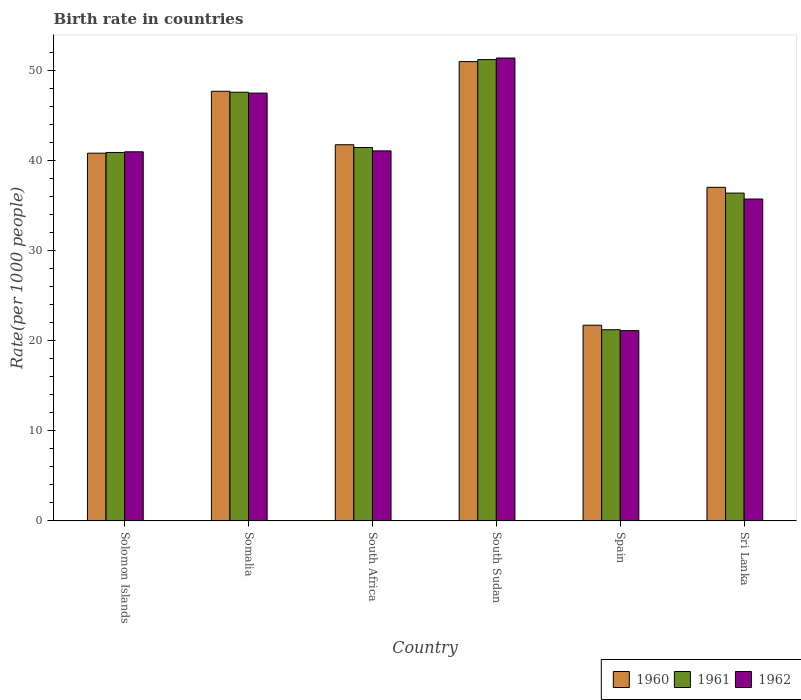Are the number of bars on each tick of the X-axis equal?
Keep it short and to the point. Yes. How many bars are there on the 5th tick from the left?
Your response must be concise. 3. What is the label of the 6th group of bars from the left?
Provide a short and direct response. Sri Lanka. In how many cases, is the number of bars for a given country not equal to the number of legend labels?
Your response must be concise. 0. What is the birth rate in 1961 in South Sudan?
Your answer should be very brief. 51.16. Across all countries, what is the maximum birth rate in 1960?
Provide a short and direct response. 50.95. Across all countries, what is the minimum birth rate in 1961?
Offer a terse response. 21.2. In which country was the birth rate in 1960 maximum?
Offer a very short reply. South Sudan. In which country was the birth rate in 1962 minimum?
Offer a very short reply. Spain. What is the total birth rate in 1961 in the graph?
Your answer should be compact. 238.54. What is the difference between the birth rate in 1962 in Solomon Islands and that in Spain?
Provide a short and direct response. 19.84. What is the difference between the birth rate in 1962 in Sri Lanka and the birth rate in 1961 in Spain?
Keep it short and to the point. 14.5. What is the average birth rate in 1960 per country?
Provide a short and direct response. 39.97. What is the difference between the birth rate of/in 1960 and birth rate of/in 1961 in South Sudan?
Make the answer very short. -0.22. What is the ratio of the birth rate in 1961 in South Africa to that in Spain?
Your answer should be very brief. 1.95. Is the birth rate in 1960 in Solomon Islands less than that in Somalia?
Provide a short and direct response. Yes. Is the difference between the birth rate in 1960 in South Sudan and Sri Lanka greater than the difference between the birth rate in 1961 in South Sudan and Sri Lanka?
Make the answer very short. No. What is the difference between the highest and the second highest birth rate in 1962?
Give a very brief answer. -10.3. What is the difference between the highest and the lowest birth rate in 1961?
Provide a succinct answer. 29.96. What does the 3rd bar from the left in Somalia represents?
Offer a very short reply. 1962. What does the 3rd bar from the right in South Sudan represents?
Your answer should be very brief. 1960. How many bars are there?
Provide a succinct answer. 18. Are all the bars in the graph horizontal?
Provide a succinct answer. No. What is the difference between two consecutive major ticks on the Y-axis?
Keep it short and to the point. 10. Are the values on the major ticks of Y-axis written in scientific E-notation?
Provide a short and direct response. No. Does the graph contain any zero values?
Make the answer very short. No. What is the title of the graph?
Provide a succinct answer. Birth rate in countries. What is the label or title of the X-axis?
Keep it short and to the point. Country. What is the label or title of the Y-axis?
Your answer should be compact. Rate(per 1000 people). What is the Rate(per 1000 people) of 1960 in Solomon Islands?
Offer a very short reply. 40.78. What is the Rate(per 1000 people) in 1961 in Solomon Islands?
Offer a very short reply. 40.86. What is the Rate(per 1000 people) in 1962 in Solomon Islands?
Provide a succinct answer. 40.94. What is the Rate(per 1000 people) of 1960 in Somalia?
Provide a short and direct response. 47.65. What is the Rate(per 1000 people) in 1961 in Somalia?
Your answer should be very brief. 47.54. What is the Rate(per 1000 people) in 1962 in Somalia?
Offer a very short reply. 47.45. What is the Rate(per 1000 people) in 1960 in South Africa?
Make the answer very short. 41.72. What is the Rate(per 1000 people) in 1961 in South Africa?
Offer a very short reply. 41.41. What is the Rate(per 1000 people) of 1962 in South Africa?
Your answer should be compact. 41.04. What is the Rate(per 1000 people) in 1960 in South Sudan?
Your response must be concise. 50.95. What is the Rate(per 1000 people) of 1961 in South Sudan?
Make the answer very short. 51.16. What is the Rate(per 1000 people) of 1962 in South Sudan?
Provide a short and direct response. 51.34. What is the Rate(per 1000 people) in 1960 in Spain?
Give a very brief answer. 21.7. What is the Rate(per 1000 people) in 1961 in Spain?
Keep it short and to the point. 21.2. What is the Rate(per 1000 people) of 1962 in Spain?
Your response must be concise. 21.1. What is the Rate(per 1000 people) of 1960 in Sri Lanka?
Offer a very short reply. 37. What is the Rate(per 1000 people) of 1961 in Sri Lanka?
Give a very brief answer. 36.36. What is the Rate(per 1000 people) in 1962 in Sri Lanka?
Your response must be concise. 35.7. Across all countries, what is the maximum Rate(per 1000 people) in 1960?
Your response must be concise. 50.95. Across all countries, what is the maximum Rate(per 1000 people) of 1961?
Offer a very short reply. 51.16. Across all countries, what is the maximum Rate(per 1000 people) in 1962?
Your answer should be compact. 51.34. Across all countries, what is the minimum Rate(per 1000 people) of 1960?
Ensure brevity in your answer.  21.7. Across all countries, what is the minimum Rate(per 1000 people) in 1961?
Your answer should be compact. 21.2. Across all countries, what is the minimum Rate(per 1000 people) of 1962?
Provide a succinct answer. 21.1. What is the total Rate(per 1000 people) of 1960 in the graph?
Give a very brief answer. 239.79. What is the total Rate(per 1000 people) of 1961 in the graph?
Ensure brevity in your answer.  238.54. What is the total Rate(per 1000 people) in 1962 in the graph?
Your response must be concise. 237.56. What is the difference between the Rate(per 1000 people) of 1960 in Solomon Islands and that in Somalia?
Offer a very short reply. -6.87. What is the difference between the Rate(per 1000 people) of 1961 in Solomon Islands and that in Somalia?
Provide a succinct answer. -6.68. What is the difference between the Rate(per 1000 people) of 1962 in Solomon Islands and that in Somalia?
Ensure brevity in your answer.  -6.51. What is the difference between the Rate(per 1000 people) of 1960 in Solomon Islands and that in South Africa?
Your answer should be compact. -0.94. What is the difference between the Rate(per 1000 people) of 1961 in Solomon Islands and that in South Africa?
Keep it short and to the point. -0.55. What is the difference between the Rate(per 1000 people) of 1962 in Solomon Islands and that in South Africa?
Your answer should be very brief. -0.1. What is the difference between the Rate(per 1000 people) of 1960 in Solomon Islands and that in South Sudan?
Provide a succinct answer. -10.16. What is the difference between the Rate(per 1000 people) in 1961 in Solomon Islands and that in South Sudan?
Your answer should be very brief. -10.3. What is the difference between the Rate(per 1000 people) of 1962 in Solomon Islands and that in South Sudan?
Keep it short and to the point. -10.4. What is the difference between the Rate(per 1000 people) of 1960 in Solomon Islands and that in Spain?
Ensure brevity in your answer.  19.08. What is the difference between the Rate(per 1000 people) of 1961 in Solomon Islands and that in Spain?
Make the answer very short. 19.66. What is the difference between the Rate(per 1000 people) in 1962 in Solomon Islands and that in Spain?
Your answer should be compact. 19.84. What is the difference between the Rate(per 1000 people) in 1960 in Solomon Islands and that in Sri Lanka?
Your answer should be compact. 3.79. What is the difference between the Rate(per 1000 people) of 1961 in Solomon Islands and that in Sri Lanka?
Ensure brevity in your answer.  4.51. What is the difference between the Rate(per 1000 people) in 1962 in Solomon Islands and that in Sri Lanka?
Give a very brief answer. 5.24. What is the difference between the Rate(per 1000 people) of 1960 in Somalia and that in South Africa?
Your answer should be compact. 5.93. What is the difference between the Rate(per 1000 people) in 1961 in Somalia and that in South Africa?
Keep it short and to the point. 6.13. What is the difference between the Rate(per 1000 people) in 1962 in Somalia and that in South Africa?
Ensure brevity in your answer.  6.41. What is the difference between the Rate(per 1000 people) of 1960 in Somalia and that in South Sudan?
Offer a very short reply. -3.29. What is the difference between the Rate(per 1000 people) of 1961 in Somalia and that in South Sudan?
Offer a very short reply. -3.62. What is the difference between the Rate(per 1000 people) of 1962 in Somalia and that in South Sudan?
Offer a very short reply. -3.89. What is the difference between the Rate(per 1000 people) of 1960 in Somalia and that in Spain?
Offer a very short reply. 25.95. What is the difference between the Rate(per 1000 people) of 1961 in Somalia and that in Spain?
Keep it short and to the point. 26.34. What is the difference between the Rate(per 1000 people) of 1962 in Somalia and that in Spain?
Give a very brief answer. 26.35. What is the difference between the Rate(per 1000 people) of 1960 in Somalia and that in Sri Lanka?
Your response must be concise. 10.65. What is the difference between the Rate(per 1000 people) of 1961 in Somalia and that in Sri Lanka?
Your answer should be compact. 11.19. What is the difference between the Rate(per 1000 people) of 1962 in Somalia and that in Sri Lanka?
Provide a succinct answer. 11.75. What is the difference between the Rate(per 1000 people) in 1960 in South Africa and that in South Sudan?
Offer a very short reply. -9.23. What is the difference between the Rate(per 1000 people) of 1961 in South Africa and that in South Sudan?
Offer a very short reply. -9.75. What is the difference between the Rate(per 1000 people) of 1962 in South Africa and that in South Sudan?
Your response must be concise. -10.3. What is the difference between the Rate(per 1000 people) in 1960 in South Africa and that in Spain?
Keep it short and to the point. 20.02. What is the difference between the Rate(per 1000 people) of 1961 in South Africa and that in Spain?
Give a very brief answer. 20.21. What is the difference between the Rate(per 1000 people) of 1962 in South Africa and that in Spain?
Offer a terse response. 19.94. What is the difference between the Rate(per 1000 people) in 1960 in South Africa and that in Sri Lanka?
Your answer should be compact. 4.72. What is the difference between the Rate(per 1000 people) of 1961 in South Africa and that in Sri Lanka?
Your answer should be compact. 5.06. What is the difference between the Rate(per 1000 people) in 1962 in South Africa and that in Sri Lanka?
Your answer should be compact. 5.34. What is the difference between the Rate(per 1000 people) of 1960 in South Sudan and that in Spain?
Offer a terse response. 29.25. What is the difference between the Rate(per 1000 people) in 1961 in South Sudan and that in Spain?
Your answer should be compact. 29.96. What is the difference between the Rate(per 1000 people) in 1962 in South Sudan and that in Spain?
Your answer should be compact. 30.24. What is the difference between the Rate(per 1000 people) in 1960 in South Sudan and that in Sri Lanka?
Give a very brief answer. 13.95. What is the difference between the Rate(per 1000 people) of 1961 in South Sudan and that in Sri Lanka?
Offer a terse response. 14.81. What is the difference between the Rate(per 1000 people) in 1962 in South Sudan and that in Sri Lanka?
Make the answer very short. 15.64. What is the difference between the Rate(per 1000 people) in 1960 in Spain and that in Sri Lanka?
Offer a terse response. -15.3. What is the difference between the Rate(per 1000 people) of 1961 in Spain and that in Sri Lanka?
Keep it short and to the point. -15.16. What is the difference between the Rate(per 1000 people) in 1962 in Spain and that in Sri Lanka?
Provide a succinct answer. -14.6. What is the difference between the Rate(per 1000 people) of 1960 in Solomon Islands and the Rate(per 1000 people) of 1961 in Somalia?
Make the answer very short. -6.76. What is the difference between the Rate(per 1000 people) of 1960 in Solomon Islands and the Rate(per 1000 people) of 1962 in Somalia?
Provide a short and direct response. -6.67. What is the difference between the Rate(per 1000 people) in 1961 in Solomon Islands and the Rate(per 1000 people) in 1962 in Somalia?
Give a very brief answer. -6.58. What is the difference between the Rate(per 1000 people) of 1960 in Solomon Islands and the Rate(per 1000 people) of 1961 in South Africa?
Ensure brevity in your answer.  -0.63. What is the difference between the Rate(per 1000 people) in 1960 in Solomon Islands and the Rate(per 1000 people) in 1962 in South Africa?
Give a very brief answer. -0.26. What is the difference between the Rate(per 1000 people) of 1961 in Solomon Islands and the Rate(per 1000 people) of 1962 in South Africa?
Make the answer very short. -0.17. What is the difference between the Rate(per 1000 people) of 1960 in Solomon Islands and the Rate(per 1000 people) of 1961 in South Sudan?
Ensure brevity in your answer.  -10.38. What is the difference between the Rate(per 1000 people) of 1960 in Solomon Islands and the Rate(per 1000 people) of 1962 in South Sudan?
Ensure brevity in your answer.  -10.56. What is the difference between the Rate(per 1000 people) in 1961 in Solomon Islands and the Rate(per 1000 people) in 1962 in South Sudan?
Offer a very short reply. -10.48. What is the difference between the Rate(per 1000 people) in 1960 in Solomon Islands and the Rate(per 1000 people) in 1961 in Spain?
Offer a terse response. 19.58. What is the difference between the Rate(per 1000 people) in 1960 in Solomon Islands and the Rate(per 1000 people) in 1962 in Spain?
Give a very brief answer. 19.68. What is the difference between the Rate(per 1000 people) of 1961 in Solomon Islands and the Rate(per 1000 people) of 1962 in Spain?
Provide a succinct answer. 19.76. What is the difference between the Rate(per 1000 people) of 1960 in Solomon Islands and the Rate(per 1000 people) of 1961 in Sri Lanka?
Offer a very short reply. 4.43. What is the difference between the Rate(per 1000 people) in 1960 in Solomon Islands and the Rate(per 1000 people) in 1962 in Sri Lanka?
Your response must be concise. 5.08. What is the difference between the Rate(per 1000 people) in 1961 in Solomon Islands and the Rate(per 1000 people) in 1962 in Sri Lanka?
Keep it short and to the point. 5.17. What is the difference between the Rate(per 1000 people) of 1960 in Somalia and the Rate(per 1000 people) of 1961 in South Africa?
Keep it short and to the point. 6.24. What is the difference between the Rate(per 1000 people) in 1960 in Somalia and the Rate(per 1000 people) in 1962 in South Africa?
Give a very brief answer. 6.61. What is the difference between the Rate(per 1000 people) in 1961 in Somalia and the Rate(per 1000 people) in 1962 in South Africa?
Keep it short and to the point. 6.5. What is the difference between the Rate(per 1000 people) in 1960 in Somalia and the Rate(per 1000 people) in 1961 in South Sudan?
Ensure brevity in your answer.  -3.51. What is the difference between the Rate(per 1000 people) of 1960 in Somalia and the Rate(per 1000 people) of 1962 in South Sudan?
Offer a very short reply. -3.69. What is the difference between the Rate(per 1000 people) of 1961 in Somalia and the Rate(per 1000 people) of 1962 in South Sudan?
Ensure brevity in your answer.  -3.8. What is the difference between the Rate(per 1000 people) of 1960 in Somalia and the Rate(per 1000 people) of 1961 in Spain?
Your answer should be very brief. 26.45. What is the difference between the Rate(per 1000 people) in 1960 in Somalia and the Rate(per 1000 people) in 1962 in Spain?
Give a very brief answer. 26.55. What is the difference between the Rate(per 1000 people) in 1961 in Somalia and the Rate(per 1000 people) in 1962 in Spain?
Keep it short and to the point. 26.44. What is the difference between the Rate(per 1000 people) in 1960 in Somalia and the Rate(per 1000 people) in 1961 in Sri Lanka?
Make the answer very short. 11.29. What is the difference between the Rate(per 1000 people) of 1960 in Somalia and the Rate(per 1000 people) of 1962 in Sri Lanka?
Keep it short and to the point. 11.95. What is the difference between the Rate(per 1000 people) of 1961 in Somalia and the Rate(per 1000 people) of 1962 in Sri Lanka?
Make the answer very short. 11.85. What is the difference between the Rate(per 1000 people) in 1960 in South Africa and the Rate(per 1000 people) in 1961 in South Sudan?
Your answer should be very brief. -9.45. What is the difference between the Rate(per 1000 people) in 1960 in South Africa and the Rate(per 1000 people) in 1962 in South Sudan?
Provide a short and direct response. -9.62. What is the difference between the Rate(per 1000 people) in 1961 in South Africa and the Rate(per 1000 people) in 1962 in South Sudan?
Keep it short and to the point. -9.93. What is the difference between the Rate(per 1000 people) of 1960 in South Africa and the Rate(per 1000 people) of 1961 in Spain?
Give a very brief answer. 20.52. What is the difference between the Rate(per 1000 people) of 1960 in South Africa and the Rate(per 1000 people) of 1962 in Spain?
Your response must be concise. 20.62. What is the difference between the Rate(per 1000 people) in 1961 in South Africa and the Rate(per 1000 people) in 1962 in Spain?
Your answer should be compact. 20.31. What is the difference between the Rate(per 1000 people) of 1960 in South Africa and the Rate(per 1000 people) of 1961 in Sri Lanka?
Ensure brevity in your answer.  5.36. What is the difference between the Rate(per 1000 people) in 1960 in South Africa and the Rate(per 1000 people) in 1962 in Sri Lanka?
Keep it short and to the point. 6.02. What is the difference between the Rate(per 1000 people) of 1961 in South Africa and the Rate(per 1000 people) of 1962 in Sri Lanka?
Your answer should be very brief. 5.71. What is the difference between the Rate(per 1000 people) in 1960 in South Sudan and the Rate(per 1000 people) in 1961 in Spain?
Give a very brief answer. 29.75. What is the difference between the Rate(per 1000 people) in 1960 in South Sudan and the Rate(per 1000 people) in 1962 in Spain?
Offer a terse response. 29.84. What is the difference between the Rate(per 1000 people) of 1961 in South Sudan and the Rate(per 1000 people) of 1962 in Spain?
Your answer should be compact. 30.07. What is the difference between the Rate(per 1000 people) of 1960 in South Sudan and the Rate(per 1000 people) of 1961 in Sri Lanka?
Make the answer very short. 14.59. What is the difference between the Rate(per 1000 people) in 1960 in South Sudan and the Rate(per 1000 people) in 1962 in Sri Lanka?
Offer a very short reply. 15.25. What is the difference between the Rate(per 1000 people) of 1961 in South Sudan and the Rate(per 1000 people) of 1962 in Sri Lanka?
Offer a terse response. 15.47. What is the difference between the Rate(per 1000 people) in 1960 in Spain and the Rate(per 1000 people) in 1961 in Sri Lanka?
Offer a very short reply. -14.66. What is the difference between the Rate(per 1000 people) of 1960 in Spain and the Rate(per 1000 people) of 1962 in Sri Lanka?
Provide a succinct answer. -14. What is the difference between the Rate(per 1000 people) of 1961 in Spain and the Rate(per 1000 people) of 1962 in Sri Lanka?
Ensure brevity in your answer.  -14.5. What is the average Rate(per 1000 people) in 1960 per country?
Keep it short and to the point. 39.97. What is the average Rate(per 1000 people) in 1961 per country?
Offer a very short reply. 39.76. What is the average Rate(per 1000 people) of 1962 per country?
Provide a succinct answer. 39.59. What is the difference between the Rate(per 1000 people) in 1960 and Rate(per 1000 people) in 1961 in Solomon Islands?
Your response must be concise. -0.08. What is the difference between the Rate(per 1000 people) in 1960 and Rate(per 1000 people) in 1962 in Solomon Islands?
Your answer should be compact. -0.15. What is the difference between the Rate(per 1000 people) of 1961 and Rate(per 1000 people) of 1962 in Solomon Islands?
Your answer should be very brief. -0.07. What is the difference between the Rate(per 1000 people) in 1960 and Rate(per 1000 people) in 1961 in Somalia?
Provide a succinct answer. 0.11. What is the difference between the Rate(per 1000 people) of 1960 and Rate(per 1000 people) of 1962 in Somalia?
Give a very brief answer. 0.2. What is the difference between the Rate(per 1000 people) of 1961 and Rate(per 1000 people) of 1962 in Somalia?
Provide a succinct answer. 0.1. What is the difference between the Rate(per 1000 people) in 1960 and Rate(per 1000 people) in 1961 in South Africa?
Offer a terse response. 0.31. What is the difference between the Rate(per 1000 people) in 1960 and Rate(per 1000 people) in 1962 in South Africa?
Provide a succinct answer. 0.68. What is the difference between the Rate(per 1000 people) of 1961 and Rate(per 1000 people) of 1962 in South Africa?
Keep it short and to the point. 0.37. What is the difference between the Rate(per 1000 people) in 1960 and Rate(per 1000 people) in 1961 in South Sudan?
Provide a succinct answer. -0.22. What is the difference between the Rate(per 1000 people) of 1960 and Rate(per 1000 people) of 1962 in South Sudan?
Your answer should be compact. -0.4. What is the difference between the Rate(per 1000 people) in 1961 and Rate(per 1000 people) in 1962 in South Sudan?
Make the answer very short. -0.18. What is the difference between the Rate(per 1000 people) of 1961 and Rate(per 1000 people) of 1962 in Spain?
Ensure brevity in your answer.  0.1. What is the difference between the Rate(per 1000 people) of 1960 and Rate(per 1000 people) of 1961 in Sri Lanka?
Offer a terse response. 0.64. What is the difference between the Rate(per 1000 people) of 1960 and Rate(per 1000 people) of 1962 in Sri Lanka?
Your response must be concise. 1.3. What is the difference between the Rate(per 1000 people) of 1961 and Rate(per 1000 people) of 1962 in Sri Lanka?
Make the answer very short. 0.66. What is the ratio of the Rate(per 1000 people) of 1960 in Solomon Islands to that in Somalia?
Provide a succinct answer. 0.86. What is the ratio of the Rate(per 1000 people) of 1961 in Solomon Islands to that in Somalia?
Your response must be concise. 0.86. What is the ratio of the Rate(per 1000 people) of 1962 in Solomon Islands to that in Somalia?
Offer a very short reply. 0.86. What is the ratio of the Rate(per 1000 people) in 1960 in Solomon Islands to that in South Africa?
Offer a terse response. 0.98. What is the ratio of the Rate(per 1000 people) of 1961 in Solomon Islands to that in South Africa?
Offer a terse response. 0.99. What is the ratio of the Rate(per 1000 people) in 1962 in Solomon Islands to that in South Africa?
Ensure brevity in your answer.  1. What is the ratio of the Rate(per 1000 people) in 1960 in Solomon Islands to that in South Sudan?
Give a very brief answer. 0.8. What is the ratio of the Rate(per 1000 people) of 1961 in Solomon Islands to that in South Sudan?
Your answer should be compact. 0.8. What is the ratio of the Rate(per 1000 people) of 1962 in Solomon Islands to that in South Sudan?
Offer a very short reply. 0.8. What is the ratio of the Rate(per 1000 people) of 1960 in Solomon Islands to that in Spain?
Your response must be concise. 1.88. What is the ratio of the Rate(per 1000 people) in 1961 in Solomon Islands to that in Spain?
Give a very brief answer. 1.93. What is the ratio of the Rate(per 1000 people) of 1962 in Solomon Islands to that in Spain?
Give a very brief answer. 1.94. What is the ratio of the Rate(per 1000 people) in 1960 in Solomon Islands to that in Sri Lanka?
Offer a terse response. 1.1. What is the ratio of the Rate(per 1000 people) in 1961 in Solomon Islands to that in Sri Lanka?
Your answer should be compact. 1.12. What is the ratio of the Rate(per 1000 people) in 1962 in Solomon Islands to that in Sri Lanka?
Provide a succinct answer. 1.15. What is the ratio of the Rate(per 1000 people) in 1960 in Somalia to that in South Africa?
Provide a succinct answer. 1.14. What is the ratio of the Rate(per 1000 people) in 1961 in Somalia to that in South Africa?
Your answer should be very brief. 1.15. What is the ratio of the Rate(per 1000 people) in 1962 in Somalia to that in South Africa?
Your answer should be compact. 1.16. What is the ratio of the Rate(per 1000 people) in 1960 in Somalia to that in South Sudan?
Your answer should be very brief. 0.94. What is the ratio of the Rate(per 1000 people) of 1961 in Somalia to that in South Sudan?
Provide a succinct answer. 0.93. What is the ratio of the Rate(per 1000 people) in 1962 in Somalia to that in South Sudan?
Your answer should be very brief. 0.92. What is the ratio of the Rate(per 1000 people) in 1960 in Somalia to that in Spain?
Ensure brevity in your answer.  2.2. What is the ratio of the Rate(per 1000 people) of 1961 in Somalia to that in Spain?
Make the answer very short. 2.24. What is the ratio of the Rate(per 1000 people) in 1962 in Somalia to that in Spain?
Offer a terse response. 2.25. What is the ratio of the Rate(per 1000 people) in 1960 in Somalia to that in Sri Lanka?
Offer a very short reply. 1.29. What is the ratio of the Rate(per 1000 people) of 1961 in Somalia to that in Sri Lanka?
Ensure brevity in your answer.  1.31. What is the ratio of the Rate(per 1000 people) in 1962 in Somalia to that in Sri Lanka?
Make the answer very short. 1.33. What is the ratio of the Rate(per 1000 people) of 1960 in South Africa to that in South Sudan?
Offer a very short reply. 0.82. What is the ratio of the Rate(per 1000 people) of 1961 in South Africa to that in South Sudan?
Offer a terse response. 0.81. What is the ratio of the Rate(per 1000 people) in 1962 in South Africa to that in South Sudan?
Your response must be concise. 0.8. What is the ratio of the Rate(per 1000 people) in 1960 in South Africa to that in Spain?
Your answer should be compact. 1.92. What is the ratio of the Rate(per 1000 people) of 1961 in South Africa to that in Spain?
Your answer should be very brief. 1.95. What is the ratio of the Rate(per 1000 people) in 1962 in South Africa to that in Spain?
Your response must be concise. 1.95. What is the ratio of the Rate(per 1000 people) of 1960 in South Africa to that in Sri Lanka?
Your response must be concise. 1.13. What is the ratio of the Rate(per 1000 people) in 1961 in South Africa to that in Sri Lanka?
Make the answer very short. 1.14. What is the ratio of the Rate(per 1000 people) in 1962 in South Africa to that in Sri Lanka?
Keep it short and to the point. 1.15. What is the ratio of the Rate(per 1000 people) of 1960 in South Sudan to that in Spain?
Keep it short and to the point. 2.35. What is the ratio of the Rate(per 1000 people) of 1961 in South Sudan to that in Spain?
Keep it short and to the point. 2.41. What is the ratio of the Rate(per 1000 people) in 1962 in South Sudan to that in Spain?
Keep it short and to the point. 2.43. What is the ratio of the Rate(per 1000 people) of 1960 in South Sudan to that in Sri Lanka?
Your answer should be very brief. 1.38. What is the ratio of the Rate(per 1000 people) in 1961 in South Sudan to that in Sri Lanka?
Keep it short and to the point. 1.41. What is the ratio of the Rate(per 1000 people) in 1962 in South Sudan to that in Sri Lanka?
Offer a very short reply. 1.44. What is the ratio of the Rate(per 1000 people) of 1960 in Spain to that in Sri Lanka?
Ensure brevity in your answer.  0.59. What is the ratio of the Rate(per 1000 people) of 1961 in Spain to that in Sri Lanka?
Provide a short and direct response. 0.58. What is the ratio of the Rate(per 1000 people) of 1962 in Spain to that in Sri Lanka?
Your answer should be very brief. 0.59. What is the difference between the highest and the second highest Rate(per 1000 people) in 1960?
Ensure brevity in your answer.  3.29. What is the difference between the highest and the second highest Rate(per 1000 people) of 1961?
Keep it short and to the point. 3.62. What is the difference between the highest and the second highest Rate(per 1000 people) of 1962?
Ensure brevity in your answer.  3.89. What is the difference between the highest and the lowest Rate(per 1000 people) in 1960?
Your answer should be very brief. 29.25. What is the difference between the highest and the lowest Rate(per 1000 people) in 1961?
Your answer should be very brief. 29.96. What is the difference between the highest and the lowest Rate(per 1000 people) of 1962?
Your answer should be compact. 30.24. 